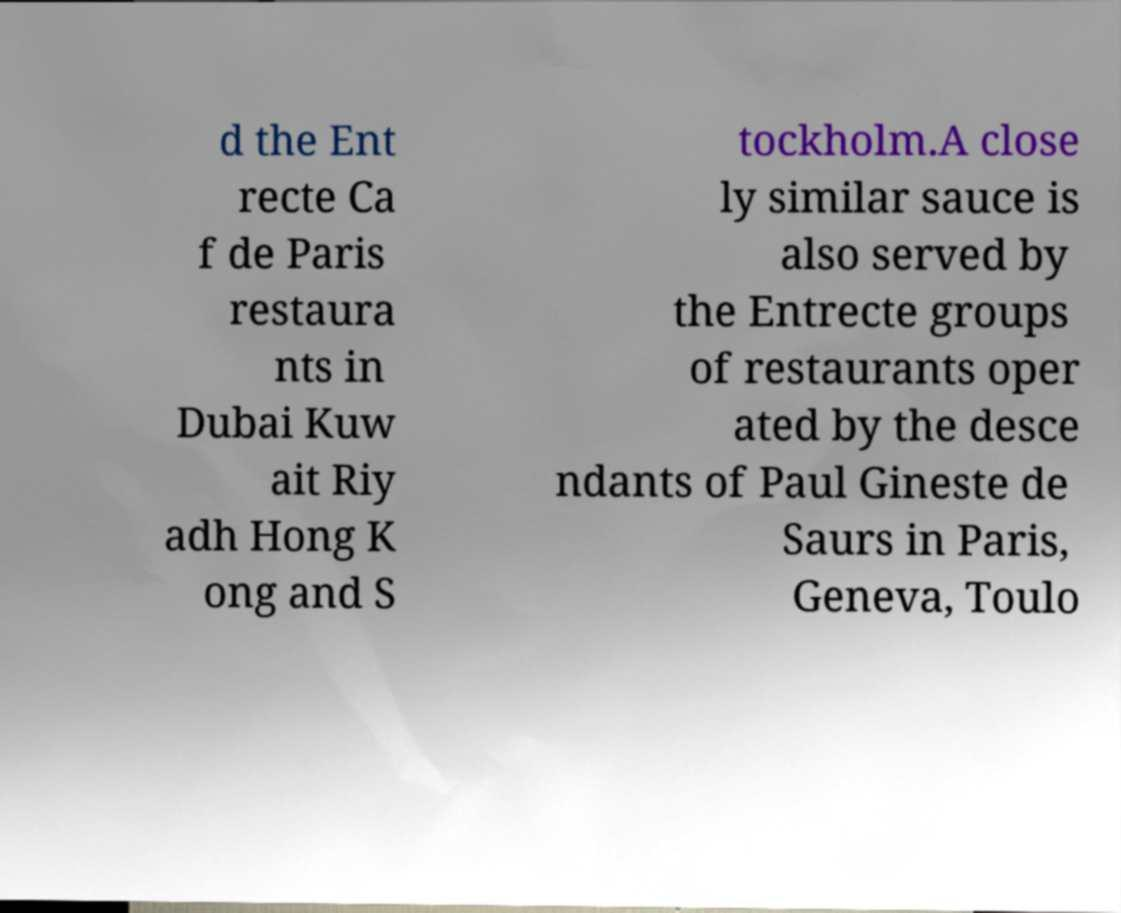Could you extract and type out the text from this image? d the Ent recte Ca f de Paris restaura nts in Dubai Kuw ait Riy adh Hong K ong and S tockholm.A close ly similar sauce is also served by the Entrecte groups of restaurants oper ated by the desce ndants of Paul Gineste de Saurs in Paris, Geneva, Toulo 